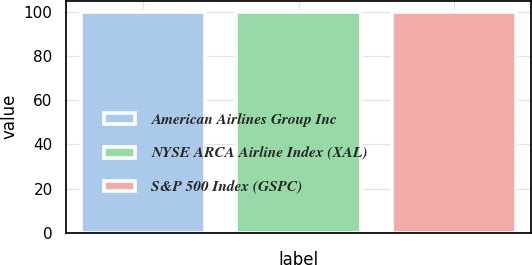<chart> <loc_0><loc_0><loc_500><loc_500><bar_chart><fcel>American Airlines Group Inc<fcel>NYSE ARCA Airline Index (XAL)<fcel>S&P 500 Index (GSPC)<nl><fcel>100<fcel>100.1<fcel>100.2<nl></chart> 